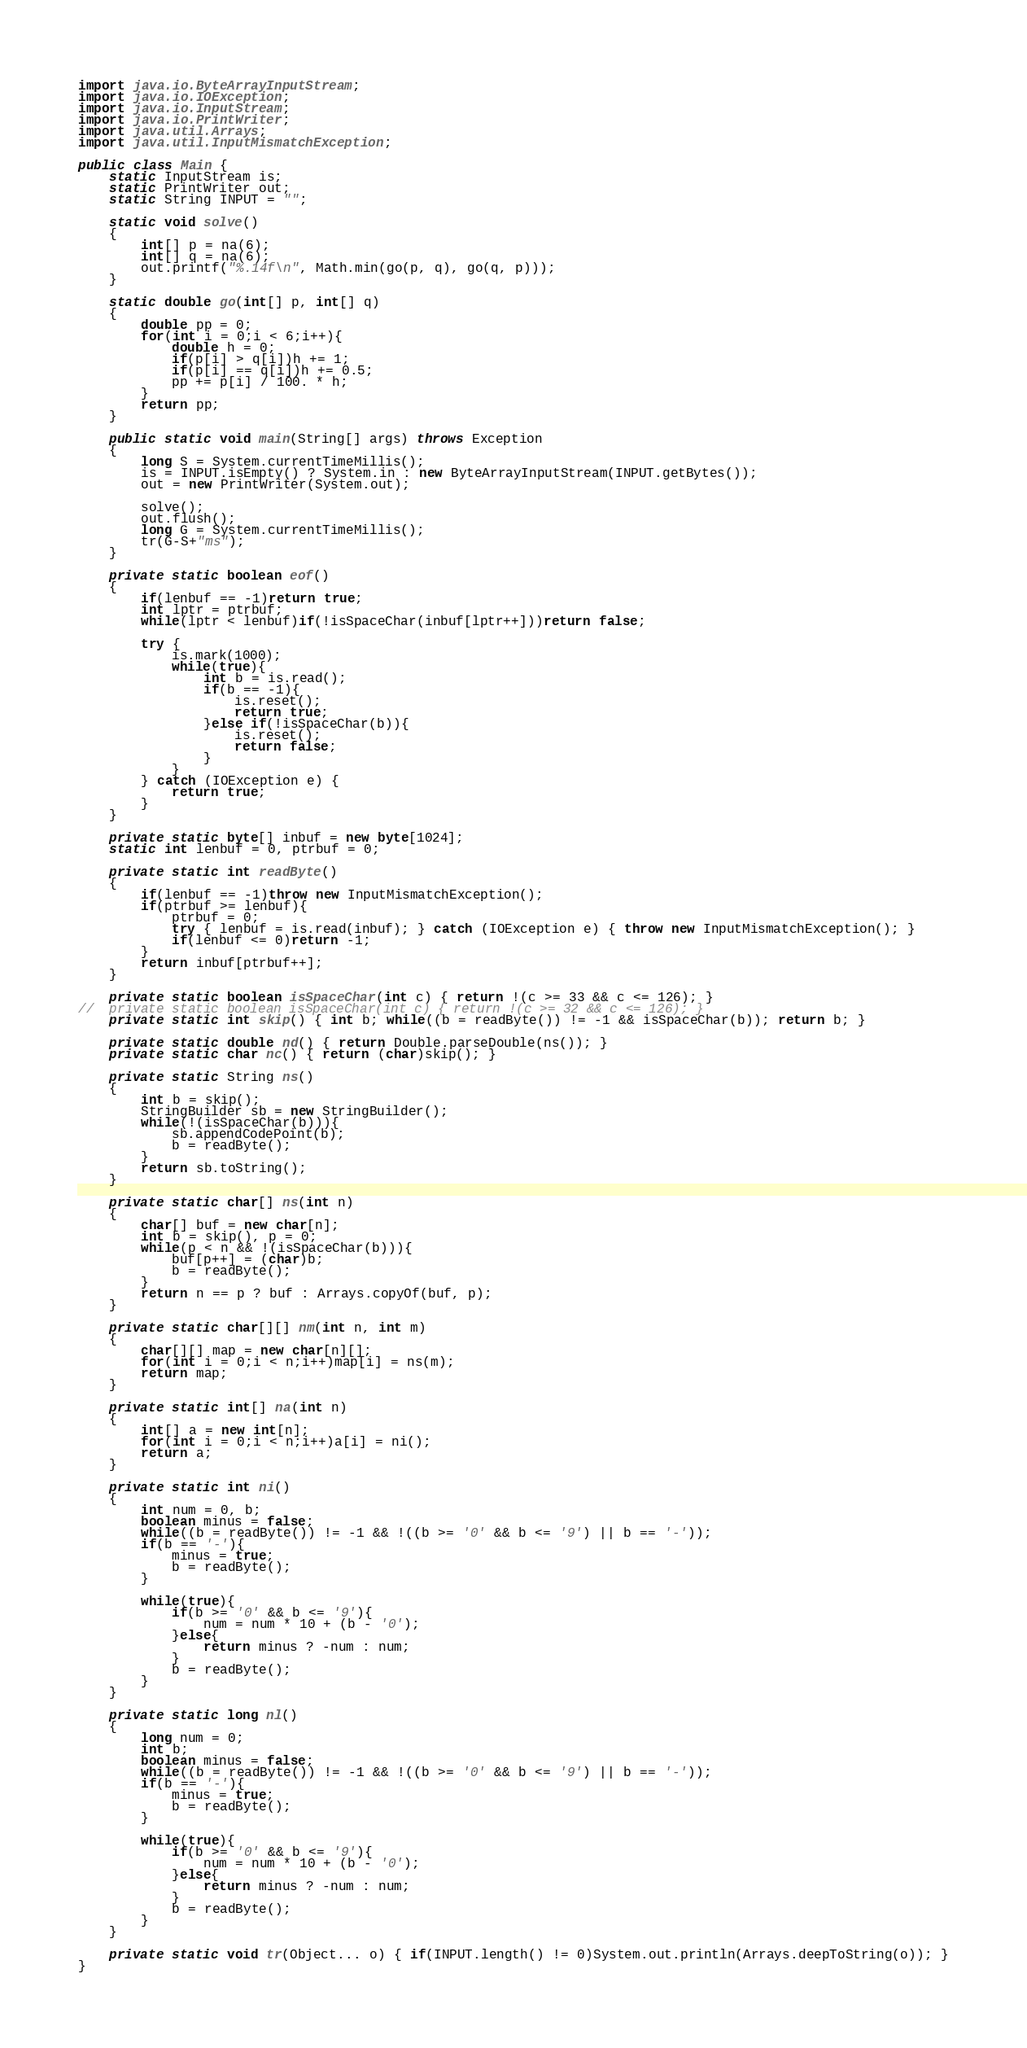<code> <loc_0><loc_0><loc_500><loc_500><_Java_>import java.io.ByteArrayInputStream;
import java.io.IOException;
import java.io.InputStream;
import java.io.PrintWriter;
import java.util.Arrays;
import java.util.InputMismatchException;

public class Main {
	static InputStream is;
	static PrintWriter out;
	static String INPUT = "";
	
	static void solve()
	{
		int[] p = na(6);
		int[] q = na(6);
		out.printf("%.14f\n", Math.min(go(p, q), go(q, p)));
	}
	
	static double go(int[] p, int[] q)
	{
		double pp = 0;
		for(int i = 0;i < 6;i++){
			double h = 0;
			if(p[i] > q[i])h += 1;
			if(p[i] == q[i])h += 0.5;
			pp += p[i] / 100. * h;
		}
		return pp;
	}
	
	public static void main(String[] args) throws Exception
	{
		long S = System.currentTimeMillis();
		is = INPUT.isEmpty() ? System.in : new ByteArrayInputStream(INPUT.getBytes());
		out = new PrintWriter(System.out);
		
		solve();
		out.flush();
		long G = System.currentTimeMillis();
		tr(G-S+"ms");
	}
	
	private static boolean eof()
	{
		if(lenbuf == -1)return true;
		int lptr = ptrbuf;
		while(lptr < lenbuf)if(!isSpaceChar(inbuf[lptr++]))return false;
		
		try {
			is.mark(1000);
			while(true){
				int b = is.read();
				if(b == -1){
					is.reset();
					return true;
				}else if(!isSpaceChar(b)){
					is.reset();
					return false;
				}
			}
		} catch (IOException e) {
			return true;
		}
	}
	
	private static byte[] inbuf = new byte[1024];
	static int lenbuf = 0, ptrbuf = 0;
	
	private static int readByte()
	{
		if(lenbuf == -1)throw new InputMismatchException();
		if(ptrbuf >= lenbuf){
			ptrbuf = 0;
			try { lenbuf = is.read(inbuf); } catch (IOException e) { throw new InputMismatchException(); }
			if(lenbuf <= 0)return -1;
		}
		return inbuf[ptrbuf++];
	}
	
	private static boolean isSpaceChar(int c) { return !(c >= 33 && c <= 126); }
//	private static boolean isSpaceChar(int c) { return !(c >= 32 && c <= 126); }
	private static int skip() { int b; while((b = readByte()) != -1 && isSpaceChar(b)); return b; }
	
	private static double nd() { return Double.parseDouble(ns()); }
	private static char nc() { return (char)skip(); }
	
	private static String ns()
	{
		int b = skip();
		StringBuilder sb = new StringBuilder();
		while(!(isSpaceChar(b))){
			sb.appendCodePoint(b);
			b = readByte();
		}
		return sb.toString();
	}
	
	private static char[] ns(int n)
	{
		char[] buf = new char[n];
		int b = skip(), p = 0;
		while(p < n && !(isSpaceChar(b))){
			buf[p++] = (char)b;
			b = readByte();
		}
		return n == p ? buf : Arrays.copyOf(buf, p);
	}
	
	private static char[][] nm(int n, int m)
	{
		char[][] map = new char[n][];
		for(int i = 0;i < n;i++)map[i] = ns(m);
		return map;
	}
	
	private static int[] na(int n)
	{
		int[] a = new int[n];
		for(int i = 0;i < n;i++)a[i] = ni();
		return a;
	}
	
	private static int ni()
	{
		int num = 0, b;
		boolean minus = false;
		while((b = readByte()) != -1 && !((b >= '0' && b <= '9') || b == '-'));
		if(b == '-'){
			minus = true;
			b = readByte();
		}
		
		while(true){
			if(b >= '0' && b <= '9'){
				num = num * 10 + (b - '0');
			}else{
				return minus ? -num : num;
			}
			b = readByte();
		}
	}
	
	private static long nl()
	{
		long num = 0;
		int b;
		boolean minus = false;
		while((b = readByte()) != -1 && !((b >= '0' && b <= '9') || b == '-'));
		if(b == '-'){
			minus = true;
			b = readByte();
		}
		
		while(true){
			if(b >= '0' && b <= '9'){
				num = num * 10 + (b - '0');
			}else{
				return minus ? -num : num;
			}
			b = readByte();
		}
	}
	
	private static void tr(Object... o) { if(INPUT.length() != 0)System.out.println(Arrays.deepToString(o)); }
}
</code> 